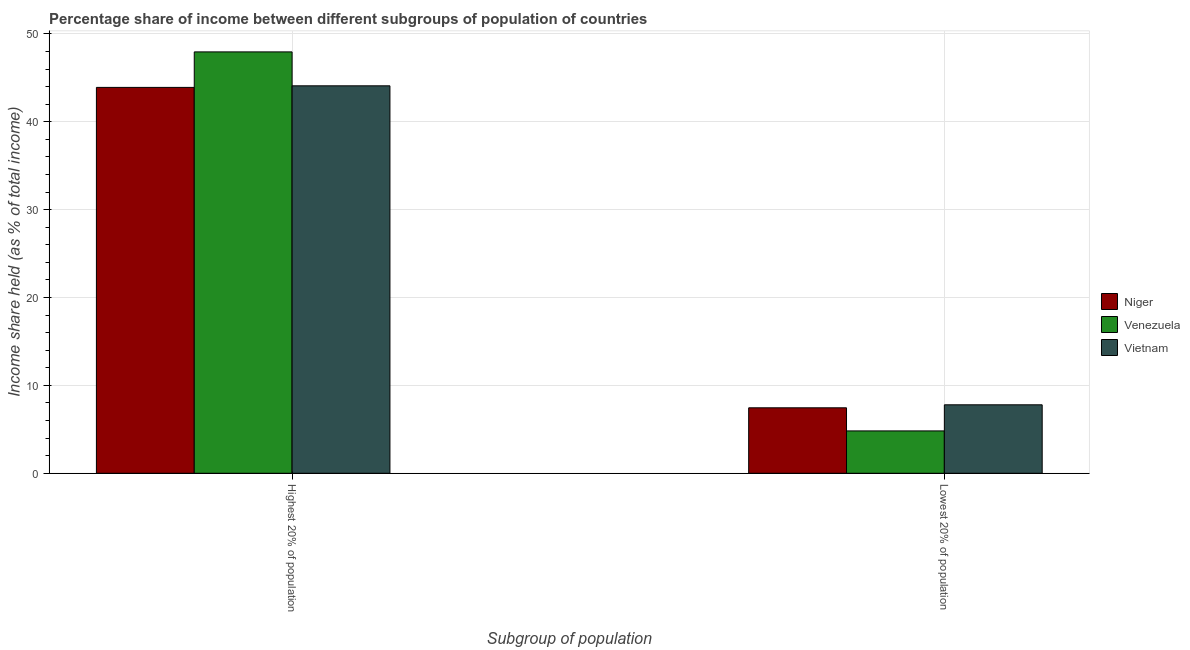Are the number of bars per tick equal to the number of legend labels?
Provide a succinct answer. Yes. What is the label of the 1st group of bars from the left?
Your answer should be very brief. Highest 20% of population. What is the income share held by lowest 20% of the population in Vietnam?
Ensure brevity in your answer.  7.79. Across all countries, what is the maximum income share held by lowest 20% of the population?
Offer a terse response. 7.79. Across all countries, what is the minimum income share held by highest 20% of the population?
Provide a succinct answer. 43.91. In which country was the income share held by highest 20% of the population maximum?
Keep it short and to the point. Venezuela. In which country was the income share held by lowest 20% of the population minimum?
Your answer should be very brief. Venezuela. What is the total income share held by highest 20% of the population in the graph?
Provide a succinct answer. 135.95. What is the difference between the income share held by highest 20% of the population in Venezuela and that in Niger?
Your answer should be very brief. 4.04. What is the difference between the income share held by lowest 20% of the population in Vietnam and the income share held by highest 20% of the population in Niger?
Your response must be concise. -36.12. What is the average income share held by lowest 20% of the population per country?
Provide a succinct answer. 6.69. What is the difference between the income share held by lowest 20% of the population and income share held by highest 20% of the population in Niger?
Provide a short and direct response. -36.46. What is the ratio of the income share held by lowest 20% of the population in Niger to that in Vietnam?
Keep it short and to the point. 0.96. In how many countries, is the income share held by lowest 20% of the population greater than the average income share held by lowest 20% of the population taken over all countries?
Your response must be concise. 2. What does the 2nd bar from the left in Lowest 20% of population represents?
Provide a succinct answer. Venezuela. What does the 2nd bar from the right in Lowest 20% of population represents?
Offer a terse response. Venezuela. How many bars are there?
Provide a succinct answer. 6. Does the graph contain any zero values?
Offer a very short reply. No. Where does the legend appear in the graph?
Offer a very short reply. Center right. How many legend labels are there?
Your answer should be very brief. 3. What is the title of the graph?
Offer a terse response. Percentage share of income between different subgroups of population of countries. Does "Finland" appear as one of the legend labels in the graph?
Your answer should be very brief. No. What is the label or title of the X-axis?
Offer a terse response. Subgroup of population. What is the label or title of the Y-axis?
Ensure brevity in your answer.  Income share held (as % of total income). What is the Income share held (as % of total income) of Niger in Highest 20% of population?
Your answer should be compact. 43.91. What is the Income share held (as % of total income) in Venezuela in Highest 20% of population?
Your answer should be compact. 47.95. What is the Income share held (as % of total income) of Vietnam in Highest 20% of population?
Offer a terse response. 44.09. What is the Income share held (as % of total income) in Niger in Lowest 20% of population?
Provide a succinct answer. 7.45. What is the Income share held (as % of total income) of Venezuela in Lowest 20% of population?
Give a very brief answer. 4.82. What is the Income share held (as % of total income) of Vietnam in Lowest 20% of population?
Make the answer very short. 7.79. Across all Subgroup of population, what is the maximum Income share held (as % of total income) in Niger?
Make the answer very short. 43.91. Across all Subgroup of population, what is the maximum Income share held (as % of total income) in Venezuela?
Offer a very short reply. 47.95. Across all Subgroup of population, what is the maximum Income share held (as % of total income) of Vietnam?
Provide a short and direct response. 44.09. Across all Subgroup of population, what is the minimum Income share held (as % of total income) of Niger?
Your answer should be very brief. 7.45. Across all Subgroup of population, what is the minimum Income share held (as % of total income) in Venezuela?
Keep it short and to the point. 4.82. Across all Subgroup of population, what is the minimum Income share held (as % of total income) of Vietnam?
Provide a succinct answer. 7.79. What is the total Income share held (as % of total income) of Niger in the graph?
Make the answer very short. 51.36. What is the total Income share held (as % of total income) of Venezuela in the graph?
Ensure brevity in your answer.  52.77. What is the total Income share held (as % of total income) in Vietnam in the graph?
Your answer should be compact. 51.88. What is the difference between the Income share held (as % of total income) of Niger in Highest 20% of population and that in Lowest 20% of population?
Provide a short and direct response. 36.46. What is the difference between the Income share held (as % of total income) of Venezuela in Highest 20% of population and that in Lowest 20% of population?
Your response must be concise. 43.13. What is the difference between the Income share held (as % of total income) in Vietnam in Highest 20% of population and that in Lowest 20% of population?
Your response must be concise. 36.3. What is the difference between the Income share held (as % of total income) of Niger in Highest 20% of population and the Income share held (as % of total income) of Venezuela in Lowest 20% of population?
Your answer should be very brief. 39.09. What is the difference between the Income share held (as % of total income) of Niger in Highest 20% of population and the Income share held (as % of total income) of Vietnam in Lowest 20% of population?
Keep it short and to the point. 36.12. What is the difference between the Income share held (as % of total income) in Venezuela in Highest 20% of population and the Income share held (as % of total income) in Vietnam in Lowest 20% of population?
Provide a succinct answer. 40.16. What is the average Income share held (as % of total income) of Niger per Subgroup of population?
Make the answer very short. 25.68. What is the average Income share held (as % of total income) of Venezuela per Subgroup of population?
Provide a succinct answer. 26.39. What is the average Income share held (as % of total income) of Vietnam per Subgroup of population?
Offer a very short reply. 25.94. What is the difference between the Income share held (as % of total income) of Niger and Income share held (as % of total income) of Venezuela in Highest 20% of population?
Offer a very short reply. -4.04. What is the difference between the Income share held (as % of total income) in Niger and Income share held (as % of total income) in Vietnam in Highest 20% of population?
Keep it short and to the point. -0.18. What is the difference between the Income share held (as % of total income) in Venezuela and Income share held (as % of total income) in Vietnam in Highest 20% of population?
Keep it short and to the point. 3.86. What is the difference between the Income share held (as % of total income) of Niger and Income share held (as % of total income) of Venezuela in Lowest 20% of population?
Your answer should be compact. 2.63. What is the difference between the Income share held (as % of total income) in Niger and Income share held (as % of total income) in Vietnam in Lowest 20% of population?
Provide a succinct answer. -0.34. What is the difference between the Income share held (as % of total income) of Venezuela and Income share held (as % of total income) of Vietnam in Lowest 20% of population?
Offer a very short reply. -2.97. What is the ratio of the Income share held (as % of total income) of Niger in Highest 20% of population to that in Lowest 20% of population?
Your answer should be compact. 5.89. What is the ratio of the Income share held (as % of total income) in Venezuela in Highest 20% of population to that in Lowest 20% of population?
Give a very brief answer. 9.95. What is the ratio of the Income share held (as % of total income) of Vietnam in Highest 20% of population to that in Lowest 20% of population?
Your answer should be very brief. 5.66. What is the difference between the highest and the second highest Income share held (as % of total income) in Niger?
Give a very brief answer. 36.46. What is the difference between the highest and the second highest Income share held (as % of total income) of Venezuela?
Give a very brief answer. 43.13. What is the difference between the highest and the second highest Income share held (as % of total income) in Vietnam?
Provide a short and direct response. 36.3. What is the difference between the highest and the lowest Income share held (as % of total income) of Niger?
Offer a very short reply. 36.46. What is the difference between the highest and the lowest Income share held (as % of total income) in Venezuela?
Provide a short and direct response. 43.13. What is the difference between the highest and the lowest Income share held (as % of total income) of Vietnam?
Your response must be concise. 36.3. 